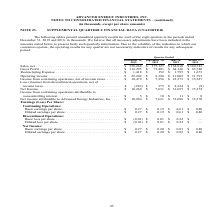According to Advanced Energy's financial document, What was the restructuring expense in  Quarter Ended  December? According to the financial document, $1,418 (in thousands). The relevant text states: "3,491 $ 64,126 $ 65,740 Restructuring Expense . $ 1,418 $ 152 $ 1,795 $ 1,673 Operating income . $ 22,202 $ 9,390 $ 11,005 $ 11,791 Income from continuing..." Also, Why are the operating results for any quarter not necessarily indicative of results for any subsequent period? volatility of the industries in which our customers operate. The document states: "ent fairly such quarterly information. Due to the volatility of the industries in which our customers operate, the operating results for any quarter a..." Also, What was the operating income in Quarter Ended  September? According to the financial document, $9,390 (in thousands). The relevant text states: "152 $ 1,795 $ 1,673 Operating income . $ 22,202 $ 9,390 $ 11,005 $ 11,791 Income from continuing operations, net of income taxes . $ 10,479 $ 7,256 $ 23,37..." Also, can you calculate: What was the change in restructuring expense between Quarter Ended  September and December? Based on the calculation: $1,418-$152, the result is 1266 (in thousands). This is based on the information: "64,126 $ 65,740 Restructuring Expense . $ 1,418 $ 152 $ 1,795 $ 1,673 Operating income . $ 22,202 $ 9,390 $ 11,005 $ 11,791 Income from continuing operat 3,491 $ 64,126 $ 65,740 Restructuring Expense ..." The key data points involved are: 1,418, 152. Also, can you calculate: What was the change in gross profit between Quarter Ended  March and June? Based on the calculation: $64,126-$65,740, the result is -1614 (in thousands). This is based on the information: "810 $ 140,743 Gross Profit . $ 112,295 $ 73,491 $ 64,126 $ 65,740 Restructuring Expense . $ 1,418 $ 152 $ 1,795 $ 1,673 Operating income . $ 22,202 $ 9,390 ,743 Gross Profit . $ 112,295 $ 73,491 $ 64,..." The key data points involved are: 64,126, 65,740. Also, can you calculate: What was the percentage change in Operating income between Quarter Ended  June and September? To answer this question, I need to perform calculations using the financial data. The calculation is: ($9,390-$11,005)/$11,005, which equals -14.68 (percentage). This is based on the information: "152 $ 1,795 $ 1,673 Operating income . $ 22,202 $ 9,390 $ 11,005 $ 11,791 Income from continuing operations, net of income taxes . $ 10,479 $ 7,256 $ 23,37 795 $ 1,673 Operating income . $ 22,202 $ 9,..." The key data points involved are: 11,005, 9,390. 